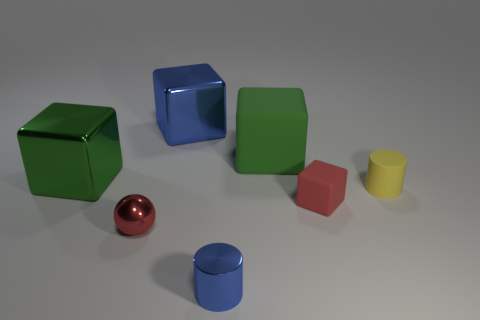Subtract all green matte blocks. How many blocks are left? 3 Add 2 large green things. How many objects exist? 9 Subtract all yellow cylinders. How many cylinders are left? 1 Subtract all spheres. How many objects are left? 6 Subtract 1 cylinders. How many cylinders are left? 1 Subtract all green cylinders. How many green spheres are left? 0 Subtract all yellow spheres. Subtract all yellow cubes. How many spheres are left? 1 Subtract all large metallic objects. Subtract all tiny cylinders. How many objects are left? 3 Add 7 big things. How many big things are left? 10 Add 6 small brown shiny spheres. How many small brown shiny spheres exist? 6 